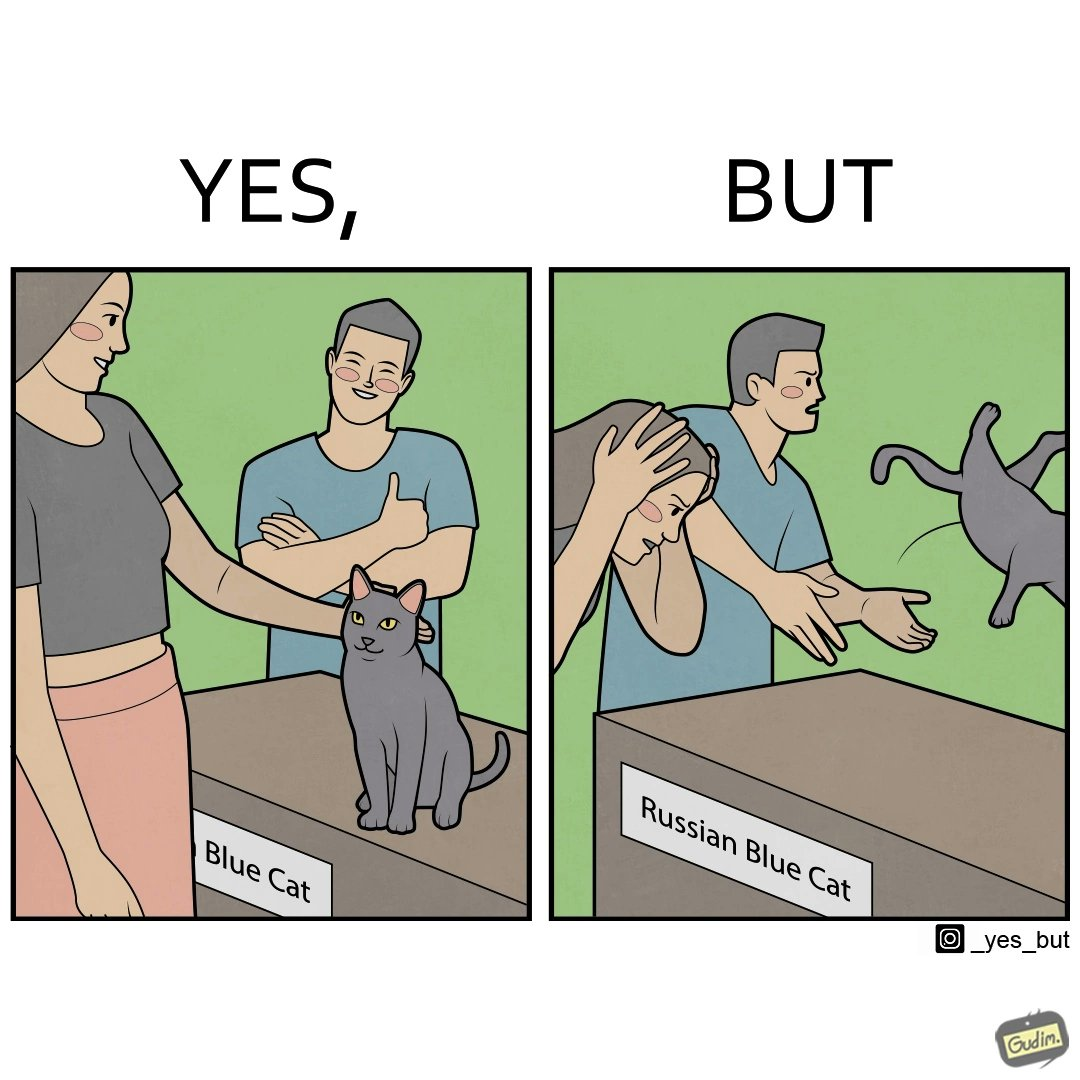Describe what you see in this image. The image is confusing, as initially, when the label reads "Blue Cat", the people are happy and are petting tha cat, but as soon as one of them realizes that the entire text reads "Russian Blue Cat", they seem to worried, and one of them throws away the cat. For some reason, the word "Russian" is a trigger word for them. 